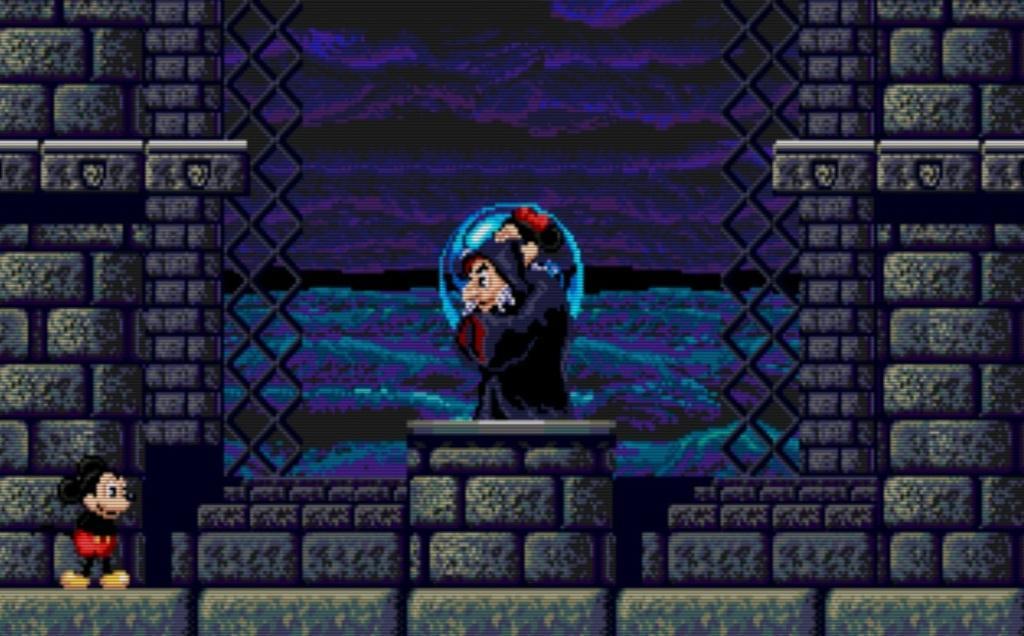In one or two sentences, can you explain what this image depicts? It is the animation image in which there is a Mickey mouse on the floor and there is a person standing on the pillar in the middle. 